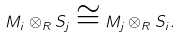Convert formula to latex. <formula><loc_0><loc_0><loc_500><loc_500>M _ { i } \otimes _ { R } S _ { j } \cong M _ { j } \otimes _ { R } S _ { i } .</formula> 